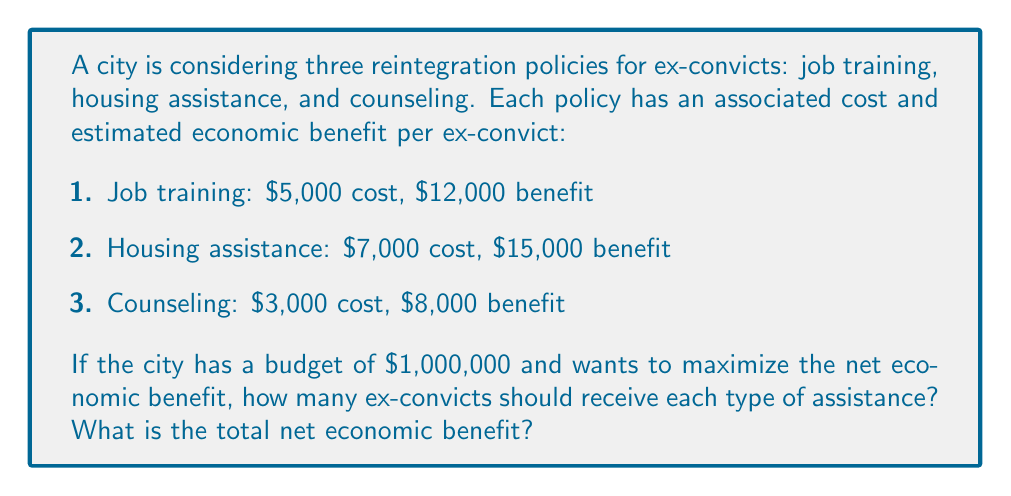Provide a solution to this math problem. To solve this problem, we need to use linear programming to maximize the net benefit subject to the budget constraint.

Let $x$, $y$, and $z$ be the number of ex-convicts receiving job training, housing assistance, and counseling, respectively.

The objective function to maximize is:
$$(12000 - 5000)x + (15000 - 7000)y + (8000 - 3000)z = 7000x + 8000y + 5000z$$

The budget constraint is:
$$5000x + 7000y + 3000z \leq 1000000$$

We need to maximize the objective function subject to this constraint and the non-negativity constraints ($x, y, z \geq 0$).

Using the simplex method or a linear programming solver, we find the optimal solution:

$x = 0$ (job training)
$y = 142$ (housing assistance)
$z = 0$ (counseling)

This means the city should provide housing assistance to 142 ex-convicts to maximize the net economic benefit.

The total net economic benefit is:
$$8000 \cdot 142 = 1,136,000$$

To verify the budget constraint:
$$7000 \cdot 142 = 994,000 \leq 1,000,000$$

Therefore, this solution is feasible and optimal.
Answer: Housing assistance for 142 ex-convicts; $1,136,000 net benefit 